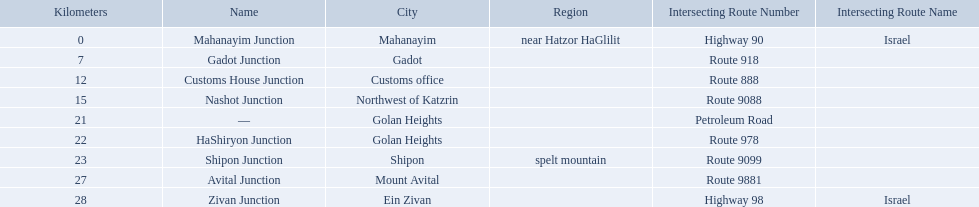What are all of the junction names? Mahanayim Junction, Gadot Junction, Customs House Junction, Nashot Junction, —, HaShiryon Junction, Shipon Junction, Avital Junction, Zivan Junction. What are their locations in kilometers? 0, 7, 12, 15, 21, 22, 23, 27, 28. Between shipon and avital, whicih is nashot closer to? Shipon Junction. Which junctions are located on numbered routes, and not highways or other types? Gadot Junction, Customs House Junction, Nashot Junction, HaShiryon Junction, Shipon Junction, Avital Junction. Of these junctions, which ones are located on routes with four digits (ex. route 9999)? Nashot Junction, Shipon Junction, Avital Junction. Of the remaining routes, which is located on shipon (spelt) mountain? Shipon Junction. How many kilometers away is shipon junction? 23. How many kilometers away is avital junction? 27. Which one is closer to nashot junction? Shipon Junction. Give me the full table as a dictionary. {'header': ['Kilometers', 'Name', 'City', 'Region', 'Intersecting Route Number', 'Intersecting Route Name'], 'rows': [['0', 'Mahanayim Junction', 'Mahanayim', 'near Hatzor HaGlilit', 'Highway 90', 'Israel'], ['7', 'Gadot Junction', 'Gadot', '', 'Route 918', ''], ['12', 'Customs House Junction', 'Customs office', '', 'Route 888', ''], ['15', 'Nashot Junction', 'Northwest of Katzrin', '', 'Route 9088', ''], ['21', '—', 'Golan Heights', '', 'Petroleum Road', ''], ['22', 'HaShiryon Junction', 'Golan Heights', '', 'Route 978', ''], ['23', 'Shipon Junction', 'Shipon', 'spelt mountain', 'Route 9099', ''], ['27', 'Avital Junction', 'Mount Avital', '', 'Route 9881', ''], ['28', 'Zivan Junction', 'Ein Zivan', '', 'Highway 98', 'Israel']]} Which junctions cross a route? Gadot Junction, Customs House Junction, Nashot Junction, HaShiryon Junction, Shipon Junction, Avital Junction. Which of these shares [art of its name with its locations name? Gadot Junction, Customs House Junction, Shipon Junction, Avital Junction. Which of them is not located in a locations named after a mountain? Gadot Junction, Customs House Junction. Which of these has the highest route number? Gadot Junction. Which intersecting routes are route 918 Route 918. What is the name? Gadot Junction. 